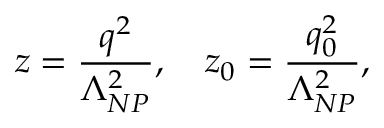<formula> <loc_0><loc_0><loc_500><loc_500>z = { \frac { q ^ { 2 } } { \Lambda _ { N P } ^ { 2 } } } , \quad z _ { 0 } = { \frac { q _ { 0 } ^ { 2 } } { \Lambda _ { N P } ^ { 2 } } } ,</formula> 